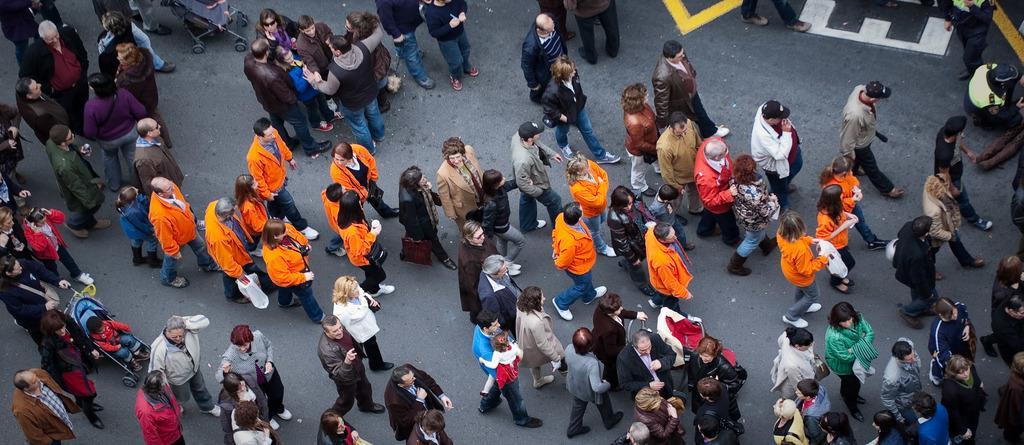Please provide a concise description of this image. In this image, we can see some people walking and there are some people standing and talking. 